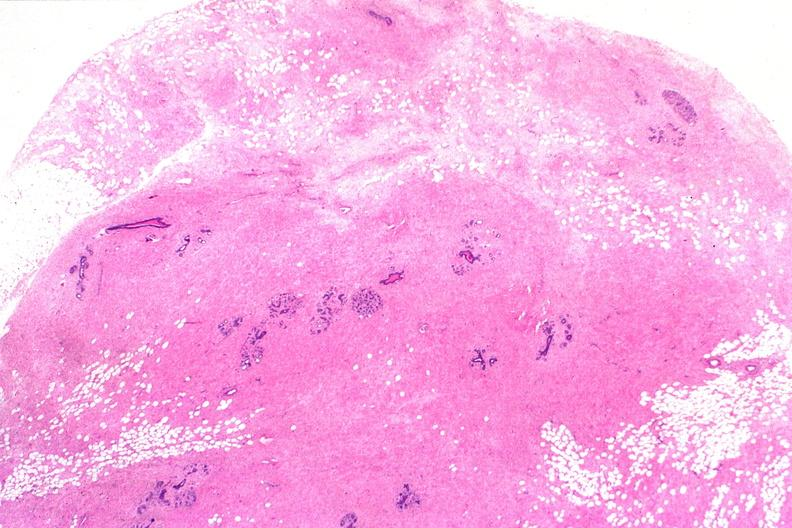what does this image show?
Answer the question using a single word or phrase. Normal breast 